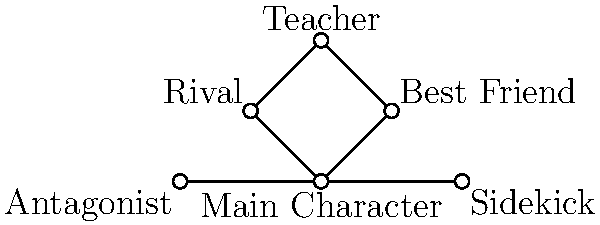In the given social network diagram representing character relationships in a children's story, which character acts as a bridge between the Main Character and the Teacher? To answer this question, we need to analyze the connections in the social network diagram:

1. Identify the Main Character: Located at the center of the diagram.
2. Identify the Teacher: Located at the top of the diagram.
3. Observe the connections:
   - The Main Character is directly connected to the Best Friend, Rival, Sidekick, and Antagonist.
   - The Teacher is directly connected to the Best Friend and the Rival.
   - There is no direct connection between the Main Character and the Teacher.
4. Find the bridge:
   - A bridge character would be connected to both the Main Character and the Teacher.
   - Both the Best Friend and the Rival are connected to the Main Character and the Teacher.
5. Conclusion:
   - Both the Best Friend and the Rival act as bridges between the Main Character and the Teacher.
   - However, the question asks for a single character, so we need to choose one.
   - In storytelling, the Best Friend is typically a more central character than the Rival.

Therefore, the Best Friend is the most likely character to act as a bridge between the Main Character and the Teacher in this story structure.
Answer: Best Friend 